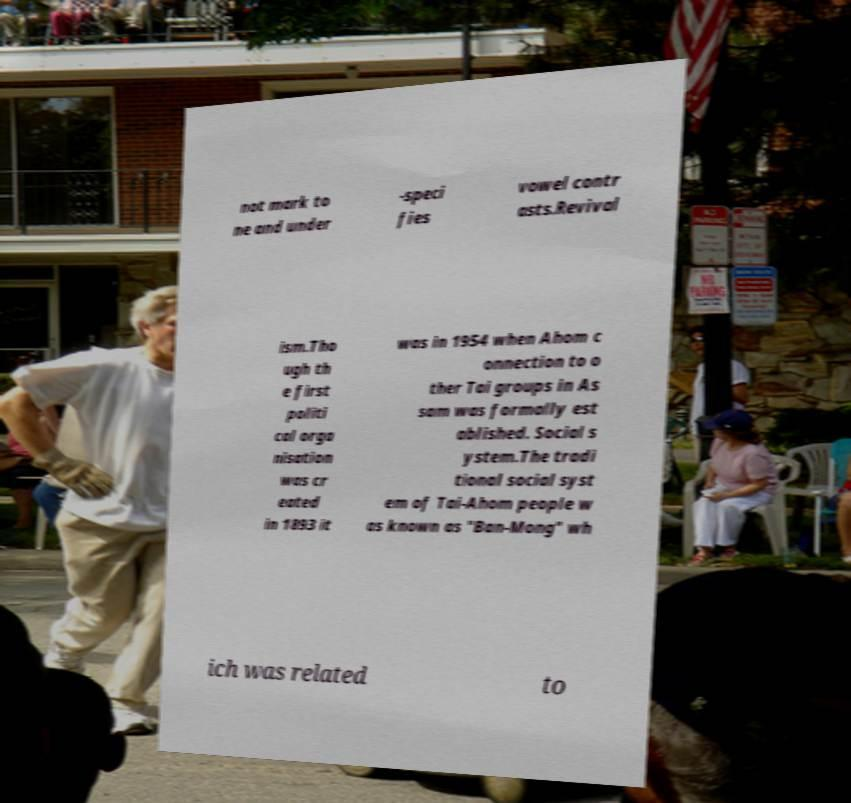There's text embedded in this image that I need extracted. Can you transcribe it verbatim? not mark to ne and under -speci fies vowel contr asts.Revival ism.Tho ugh th e first politi cal orga nisation was cr eated in 1893 it was in 1954 when Ahom c onnection to o ther Tai groups in As sam was formally est ablished. Social s ystem.The tradi tional social syst em of Tai-Ahom people w as known as "Ban-Mong" wh ich was related to 